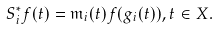Convert formula to latex. <formula><loc_0><loc_0><loc_500><loc_500>S _ { i } ^ { * } f ( t ) = \mathfrak { m } _ { i } ( t ) f ( g _ { i } ( t ) ) , t \in X .</formula> 